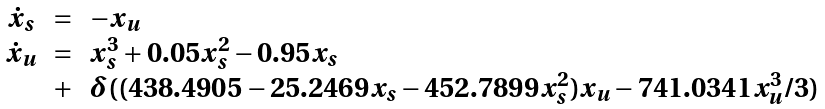<formula> <loc_0><loc_0><loc_500><loc_500>\begin{array} { c c l } \dot { x } _ { s } & = & - x _ { u } \\ \dot { x } _ { u } & = & x _ { s } ^ { 3 } + 0 . 0 5 x _ { s } ^ { 2 } - 0 . 9 5 x _ { s } \\ & + & \delta ( ( 4 3 8 . 4 9 0 5 - 2 5 . 2 4 6 9 x _ { s } - 4 5 2 . 7 8 9 9 x _ { s } ^ { 2 } ) x _ { u } - 7 4 1 . 0 3 4 1 x _ { u } ^ { 3 } / 3 ) \end{array}</formula> 